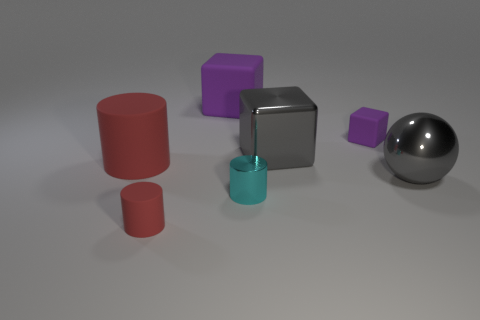There is a purple block left of the shiny cylinder; is its size the same as the metallic block?
Offer a terse response. Yes. There is a rubber block that is left of the tiny cyan thing; what is its size?
Give a very brief answer. Large. How many cyan cylinders are there?
Offer a terse response. 1. Do the large matte cylinder and the small matte cylinder have the same color?
Offer a terse response. Yes. The rubber thing that is both in front of the tiny matte block and right of the large red matte cylinder is what color?
Give a very brief answer. Red. Are there any metal spheres in front of the small cyan shiny object?
Offer a very short reply. No. What number of small purple objects are to the right of the purple cube that is in front of the big purple matte object?
Provide a short and direct response. 0. What is the size of the cyan cylinder that is the same material as the big gray cube?
Give a very brief answer. Small. The shiny cube is what size?
Provide a succinct answer. Large. Is the tiny cyan object made of the same material as the big red object?
Give a very brief answer. No. 